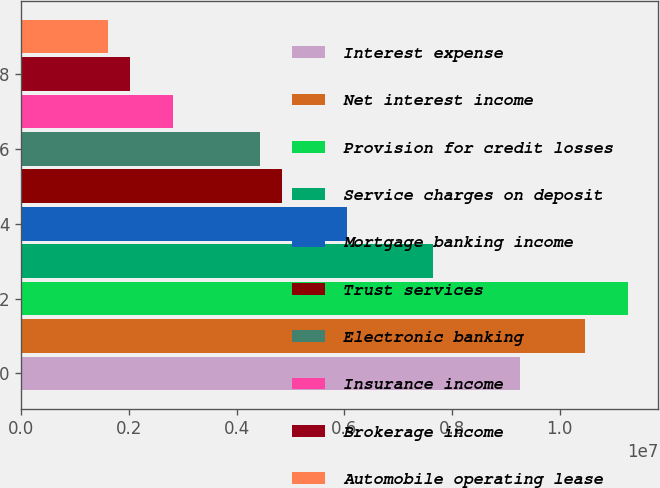Convert chart. <chart><loc_0><loc_0><loc_500><loc_500><bar_chart><fcel>Interest expense<fcel>Net interest income<fcel>Provision for credit losses<fcel>Service charges on deposit<fcel>Mortgage banking income<fcel>Trust services<fcel>Electronic banking<fcel>Insurance income<fcel>Brokerage income<fcel>Automobile operating lease<nl><fcel>9.2636e+06<fcel>1.04706e+07<fcel>1.12752e+07<fcel>7.65432e+06<fcel>6.04504e+06<fcel>4.83808e+06<fcel>4.43576e+06<fcel>2.82648e+06<fcel>2.02185e+06<fcel>1.61953e+06<nl></chart> 